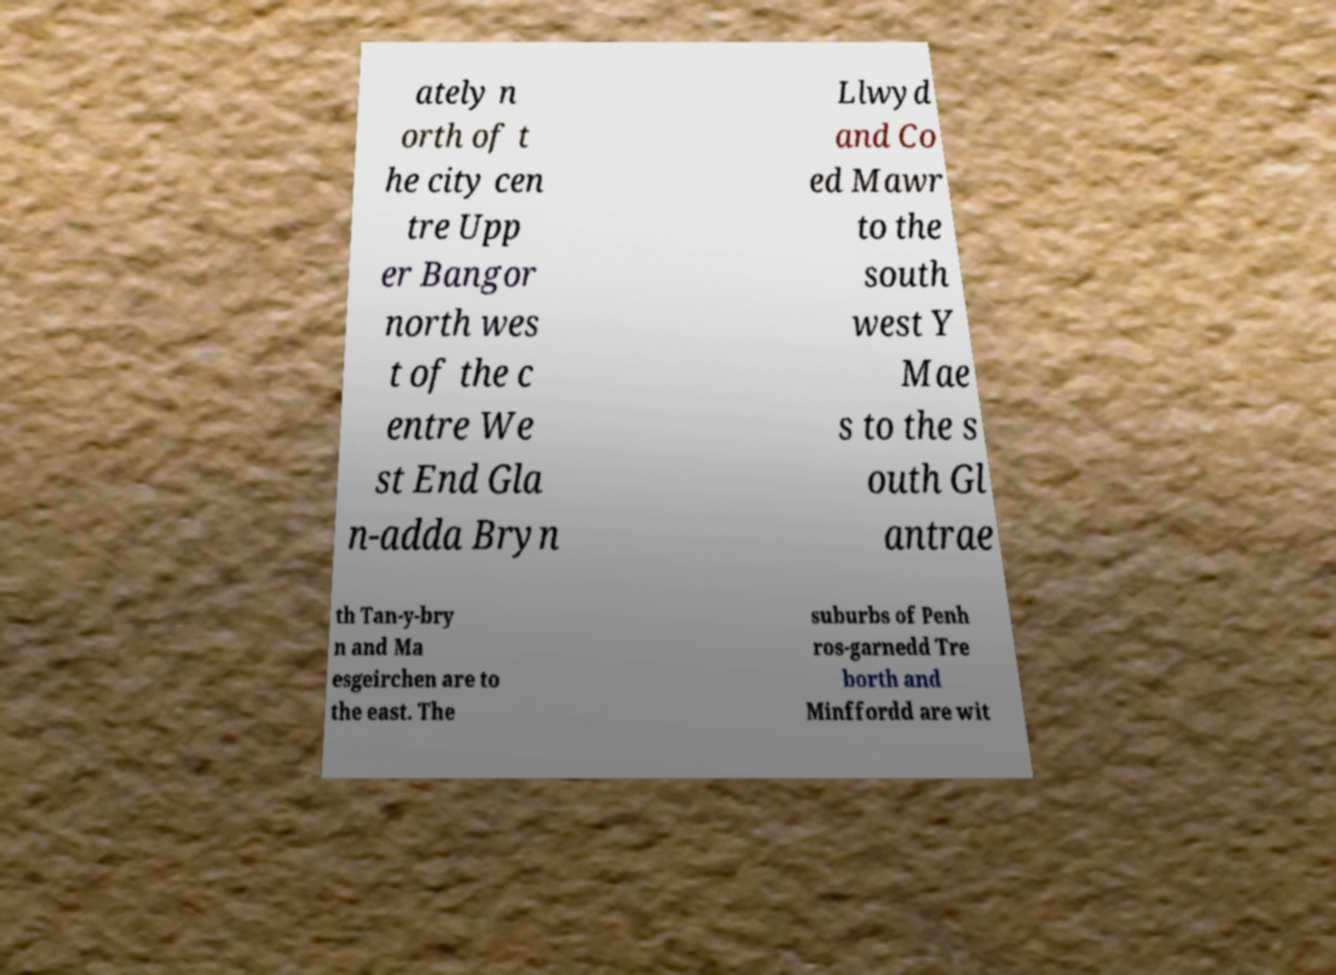What messages or text are displayed in this image? I need them in a readable, typed format. ately n orth of t he city cen tre Upp er Bangor north wes t of the c entre We st End Gla n-adda Bryn Llwyd and Co ed Mawr to the south west Y Mae s to the s outh Gl antrae th Tan-y-bry n and Ma esgeirchen are to the east. The suburbs of Penh ros-garnedd Tre borth and Minffordd are wit 